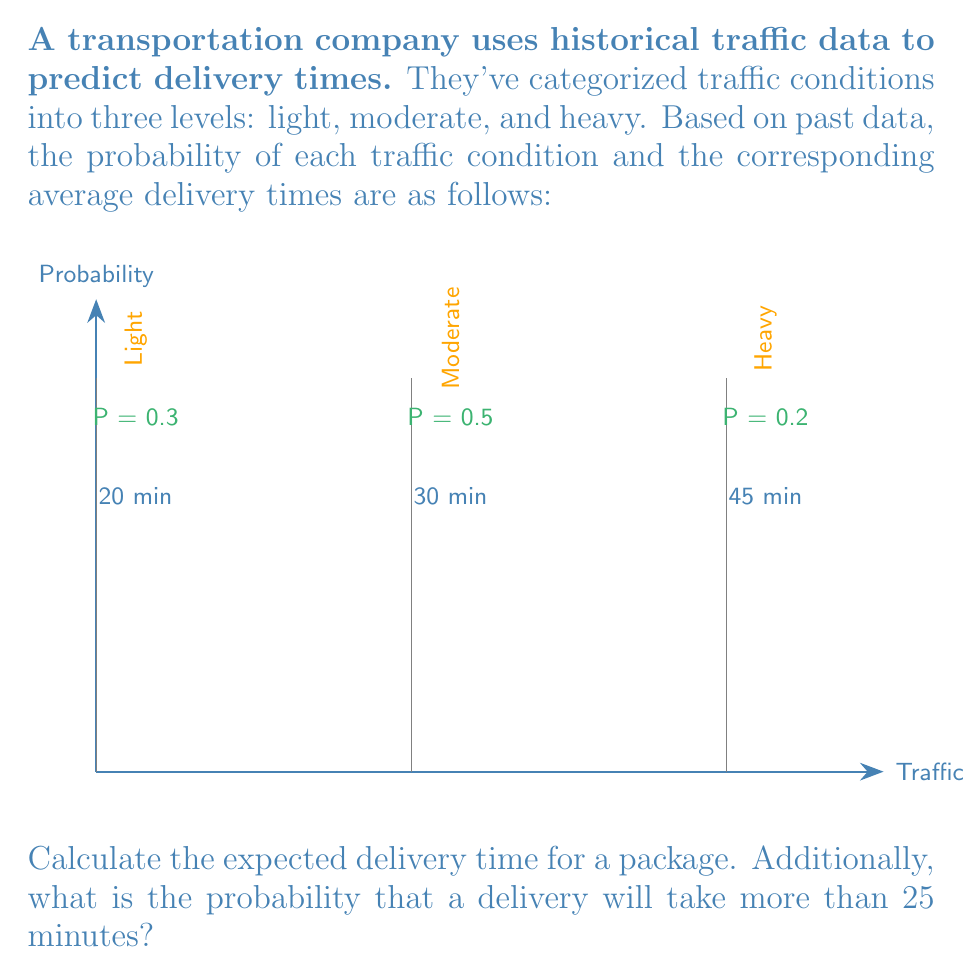Teach me how to tackle this problem. Let's approach this problem step by step:

1. Calculate the expected delivery time:
   The expected value is the sum of each possible outcome multiplied by its probability.

   $$E(T) = \sum_{i=1}^{n} p_i \cdot t_i$$

   Where $p_i$ is the probability of each traffic condition and $t_i$ is the corresponding delivery time.

   $$E(T) = (0.3 \cdot 20) + (0.5 \cdot 30) + (0.2 \cdot 45)$$
   $$E(T) = 6 + 15 + 9 = 30\text{ minutes}$$

2. Calculate the probability that a delivery will take more than 25 minutes:
   We need to sum the probabilities of all conditions where the delivery time exceeds 25 minutes.

   $$P(T > 25) = P(\text{Moderate}) + P(\text{Heavy})$$
   $$P(T > 25) = 0.5 + 0.2 = 0.7$$

Thus, there's a 70% chance that a delivery will take more than 25 minutes.
Answer: Expected delivery time: 30 minutes
Probability of delivery taking > 25 minutes: 0.7 